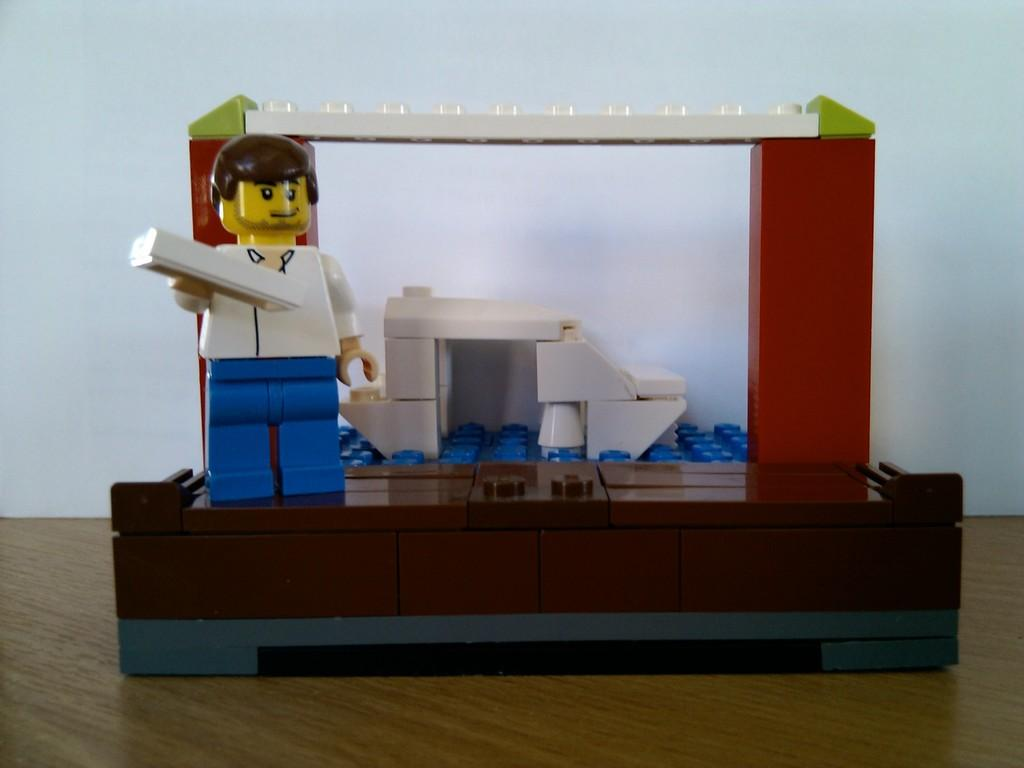What is the main subject on the left side of the image? There is a shape resembling a man on the left side of the image. What is located behind the shape in the image? There is a wall behind the shape in the image. How many hands does the toad have in the image? There is no toad present in the image, and therefore no hands to count. 